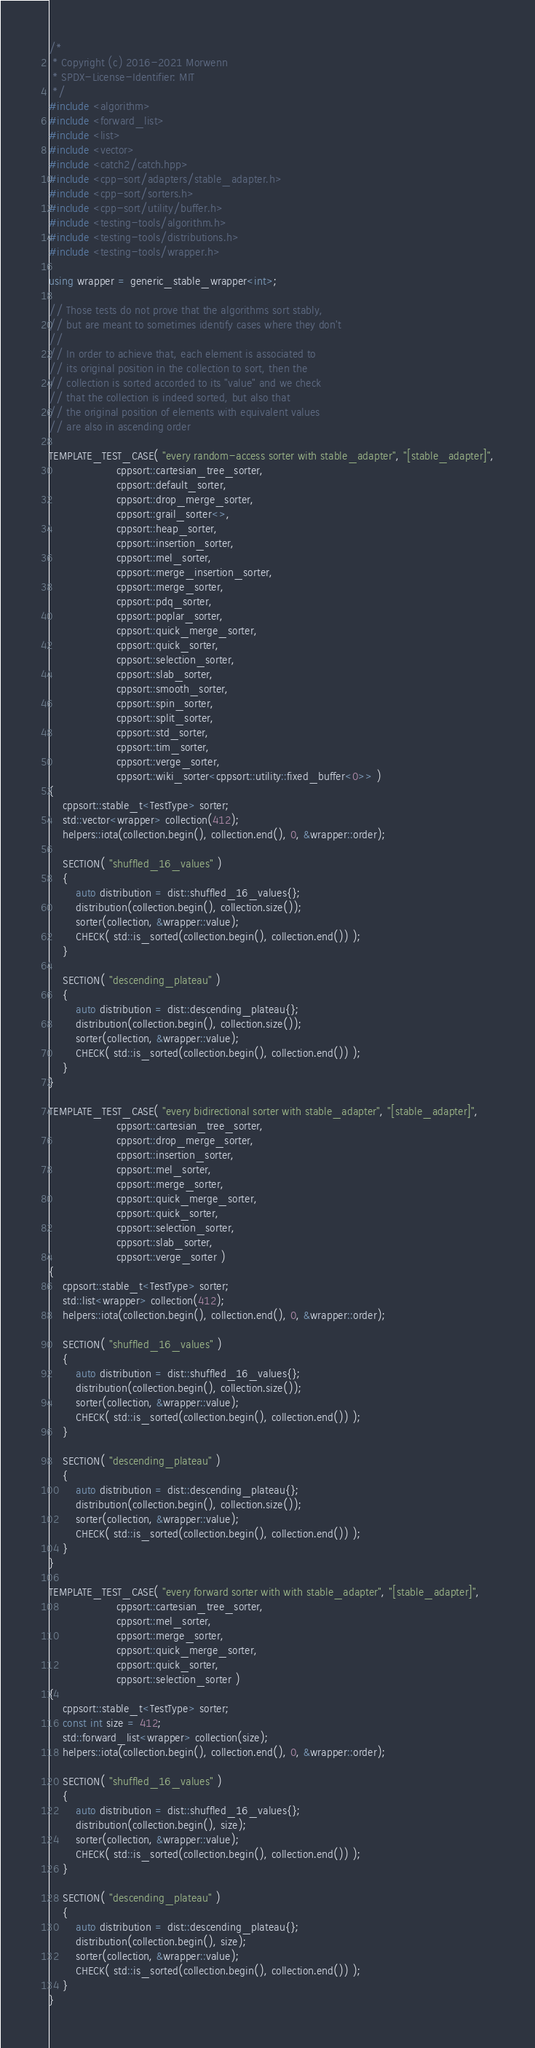Convert code to text. <code><loc_0><loc_0><loc_500><loc_500><_C++_>/*
 * Copyright (c) 2016-2021 Morwenn
 * SPDX-License-Identifier: MIT
 */
#include <algorithm>
#include <forward_list>
#include <list>
#include <vector>
#include <catch2/catch.hpp>
#include <cpp-sort/adapters/stable_adapter.h>
#include <cpp-sort/sorters.h>
#include <cpp-sort/utility/buffer.h>
#include <testing-tools/algorithm.h>
#include <testing-tools/distributions.h>
#include <testing-tools/wrapper.h>

using wrapper = generic_stable_wrapper<int>;

// Those tests do not prove that the algorithms sort stably,
// but are meant to sometimes identify cases where they don't
//
// In order to achieve that, each element is associated to
// its original position in the collection to sort, then the
// collection is sorted accorded to its "value" and we check
// that the collection is indeed sorted, but also that
// the original position of elements with equivalent values
// are also in ascending order

TEMPLATE_TEST_CASE( "every random-access sorter with stable_adapter", "[stable_adapter]",
                    cppsort::cartesian_tree_sorter,
                    cppsort::default_sorter,
                    cppsort::drop_merge_sorter,
                    cppsort::grail_sorter<>,
                    cppsort::heap_sorter,
                    cppsort::insertion_sorter,
                    cppsort::mel_sorter,
                    cppsort::merge_insertion_sorter,
                    cppsort::merge_sorter,
                    cppsort::pdq_sorter,
                    cppsort::poplar_sorter,
                    cppsort::quick_merge_sorter,
                    cppsort::quick_sorter,
                    cppsort::selection_sorter,
                    cppsort::slab_sorter,
                    cppsort::smooth_sorter,
                    cppsort::spin_sorter,
                    cppsort::split_sorter,
                    cppsort::std_sorter,
                    cppsort::tim_sorter,
                    cppsort::verge_sorter,
                    cppsort::wiki_sorter<cppsort::utility::fixed_buffer<0>> )
{
    cppsort::stable_t<TestType> sorter;
    std::vector<wrapper> collection(412);
    helpers::iota(collection.begin(), collection.end(), 0, &wrapper::order);

    SECTION( "shuffled_16_values" )
    {
        auto distribution = dist::shuffled_16_values{};
        distribution(collection.begin(), collection.size());
        sorter(collection, &wrapper::value);
        CHECK( std::is_sorted(collection.begin(), collection.end()) );
    }

    SECTION( "descending_plateau" )
    {
        auto distribution = dist::descending_plateau{};
        distribution(collection.begin(), collection.size());
        sorter(collection, &wrapper::value);
        CHECK( std::is_sorted(collection.begin(), collection.end()) );
    }
}

TEMPLATE_TEST_CASE( "every bidirectional sorter with stable_adapter", "[stable_adapter]",
                    cppsort::cartesian_tree_sorter,
                    cppsort::drop_merge_sorter,
                    cppsort::insertion_sorter,
                    cppsort::mel_sorter,
                    cppsort::merge_sorter,
                    cppsort::quick_merge_sorter,
                    cppsort::quick_sorter,
                    cppsort::selection_sorter,
                    cppsort::slab_sorter,
                    cppsort::verge_sorter )
{
    cppsort::stable_t<TestType> sorter;
    std::list<wrapper> collection(412);
    helpers::iota(collection.begin(), collection.end(), 0, &wrapper::order);

    SECTION( "shuffled_16_values" )
    {
        auto distribution = dist::shuffled_16_values{};
        distribution(collection.begin(), collection.size());
        sorter(collection, &wrapper::value);
        CHECK( std::is_sorted(collection.begin(), collection.end()) );
    }

    SECTION( "descending_plateau" )
    {
        auto distribution = dist::descending_plateau{};
        distribution(collection.begin(), collection.size());
        sorter(collection, &wrapper::value);
        CHECK( std::is_sorted(collection.begin(), collection.end()) );
    }
}

TEMPLATE_TEST_CASE( "every forward sorter with with stable_adapter", "[stable_adapter]",
                    cppsort::cartesian_tree_sorter,
                    cppsort::mel_sorter,
                    cppsort::merge_sorter,
                    cppsort::quick_merge_sorter,
                    cppsort::quick_sorter,
                    cppsort::selection_sorter )
{
    cppsort::stable_t<TestType> sorter;
    const int size = 412;
    std::forward_list<wrapper> collection(size);
    helpers::iota(collection.begin(), collection.end(), 0, &wrapper::order);

    SECTION( "shuffled_16_values" )
    {
        auto distribution = dist::shuffled_16_values{};
        distribution(collection.begin(), size);
        sorter(collection, &wrapper::value);
        CHECK( std::is_sorted(collection.begin(), collection.end()) );
    }

    SECTION( "descending_plateau" )
    {
        auto distribution = dist::descending_plateau{};
        distribution(collection.begin(), size);
        sorter(collection, &wrapper::value);
        CHECK( std::is_sorted(collection.begin(), collection.end()) );
    }
}
</code> 